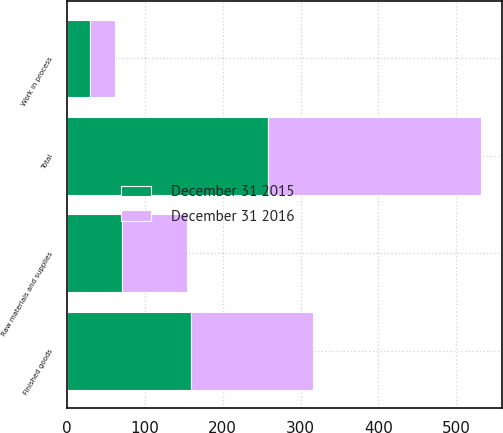Convert chart to OTSL. <chart><loc_0><loc_0><loc_500><loc_500><stacked_bar_chart><ecel><fcel>Raw materials and supplies<fcel>Work in process<fcel>Finished goods<fcel>Total<nl><fcel>December 31 2015<fcel>69.8<fcel>28.8<fcel>159.6<fcel>258.2<nl><fcel>December 31 2016<fcel>84.6<fcel>33.1<fcel>156.3<fcel>274<nl></chart> 